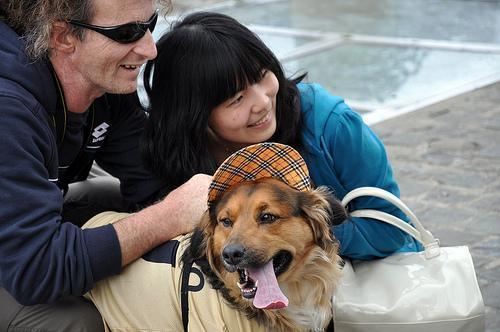How many people are in the picture?
Give a very brief answer. 2. How many animals are in the picture?
Give a very brief answer. 1. 